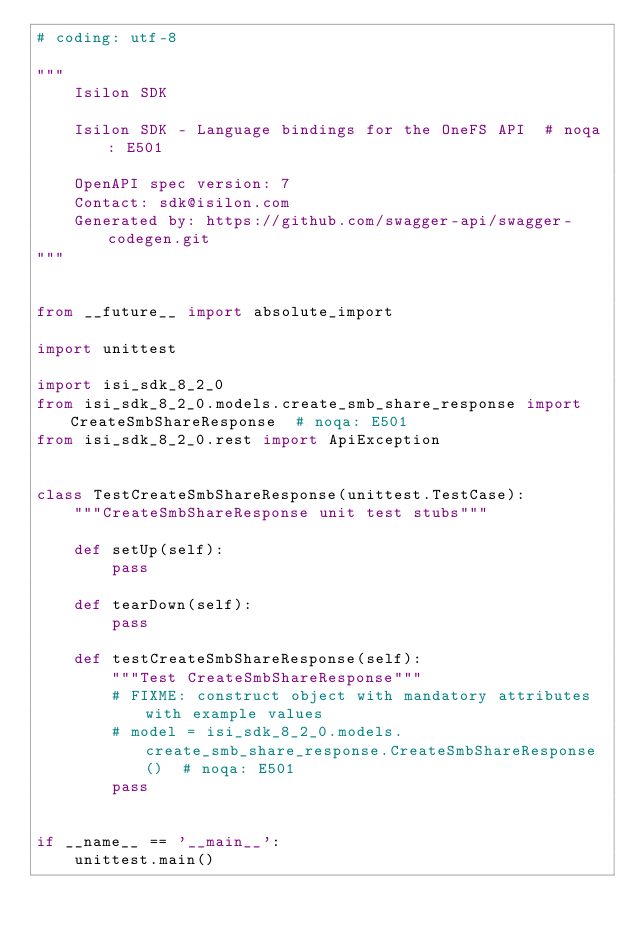<code> <loc_0><loc_0><loc_500><loc_500><_Python_># coding: utf-8

"""
    Isilon SDK

    Isilon SDK - Language bindings for the OneFS API  # noqa: E501

    OpenAPI spec version: 7
    Contact: sdk@isilon.com
    Generated by: https://github.com/swagger-api/swagger-codegen.git
"""


from __future__ import absolute_import

import unittest

import isi_sdk_8_2_0
from isi_sdk_8_2_0.models.create_smb_share_response import CreateSmbShareResponse  # noqa: E501
from isi_sdk_8_2_0.rest import ApiException


class TestCreateSmbShareResponse(unittest.TestCase):
    """CreateSmbShareResponse unit test stubs"""

    def setUp(self):
        pass

    def tearDown(self):
        pass

    def testCreateSmbShareResponse(self):
        """Test CreateSmbShareResponse"""
        # FIXME: construct object with mandatory attributes with example values
        # model = isi_sdk_8_2_0.models.create_smb_share_response.CreateSmbShareResponse()  # noqa: E501
        pass


if __name__ == '__main__':
    unittest.main()
</code> 